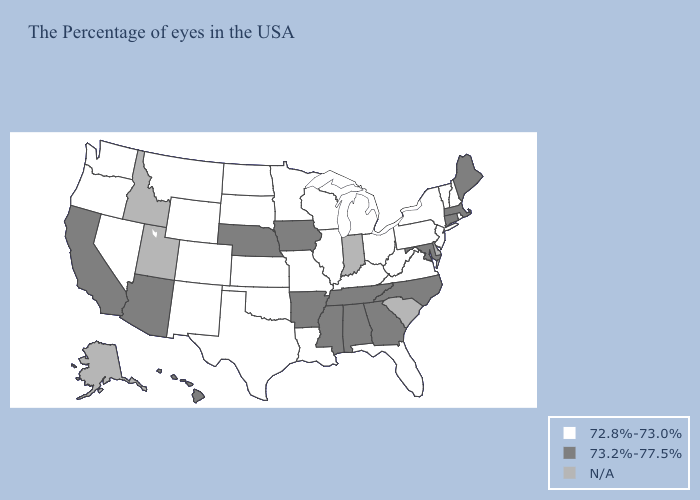Name the states that have a value in the range N/A?
Answer briefly. Delaware, South Carolina, Indiana, Utah, Idaho, Alaska. Does Mississippi have the highest value in the USA?
Answer briefly. Yes. Name the states that have a value in the range 73.2%-77.5%?
Concise answer only. Maine, Massachusetts, Connecticut, Maryland, North Carolina, Georgia, Alabama, Tennessee, Mississippi, Arkansas, Iowa, Nebraska, Arizona, California, Hawaii. What is the value of Mississippi?
Write a very short answer. 73.2%-77.5%. Does the map have missing data?
Keep it brief. Yes. What is the lowest value in the South?
Give a very brief answer. 72.8%-73.0%. Name the states that have a value in the range 73.2%-77.5%?
Write a very short answer. Maine, Massachusetts, Connecticut, Maryland, North Carolina, Georgia, Alabama, Tennessee, Mississippi, Arkansas, Iowa, Nebraska, Arizona, California, Hawaii. Among the states that border Wisconsin , does Iowa have the lowest value?
Quick response, please. No. Which states have the lowest value in the USA?
Keep it brief. Rhode Island, New Hampshire, Vermont, New York, New Jersey, Pennsylvania, Virginia, West Virginia, Ohio, Florida, Michigan, Kentucky, Wisconsin, Illinois, Louisiana, Missouri, Minnesota, Kansas, Oklahoma, Texas, South Dakota, North Dakota, Wyoming, Colorado, New Mexico, Montana, Nevada, Washington, Oregon. Among the states that border Nebraska , which have the lowest value?
Quick response, please. Missouri, Kansas, South Dakota, Wyoming, Colorado. What is the value of Montana?
Answer briefly. 72.8%-73.0%. Among the states that border Idaho , which have the lowest value?
Short answer required. Wyoming, Montana, Nevada, Washington, Oregon. Which states have the highest value in the USA?
Be succinct. Maine, Massachusetts, Connecticut, Maryland, North Carolina, Georgia, Alabama, Tennessee, Mississippi, Arkansas, Iowa, Nebraska, Arizona, California, Hawaii. 